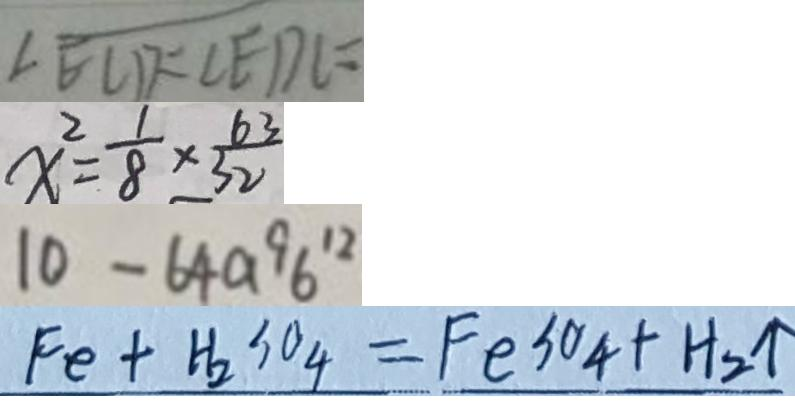<formula> <loc_0><loc_0><loc_500><loc_500>\angle E C D = \angle E D C = 
 x ^ { 2 } = \frac { 1 } { 8 } \times \frac { 6 3 } { 3 2 } 
 1 0 - 6 4 a ^ { 9 } 6 ^ { 1 2 } 
 F e + H _ { 2 } S O _ { 4 } = F e S 0 _ { 4 } + H _ { 2 } \uparrow</formula> 